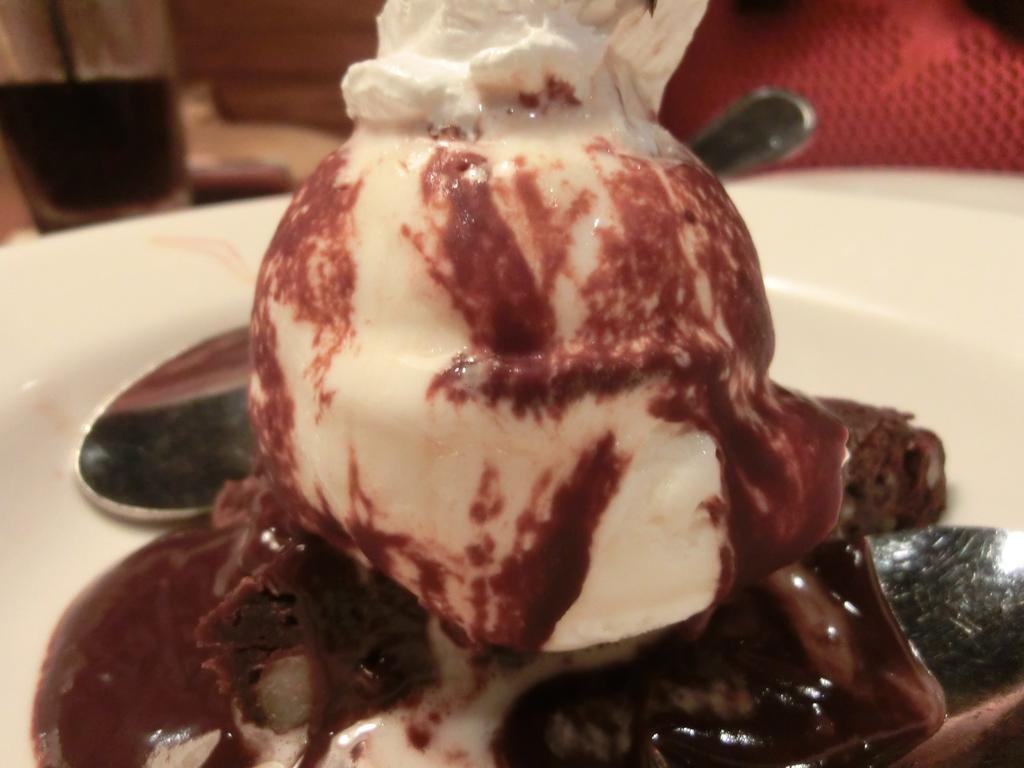Can you describe this image briefly? In this image, I can see an ice cream on a piece of cake and two spoons on a plate. In the background, there are few objects. 